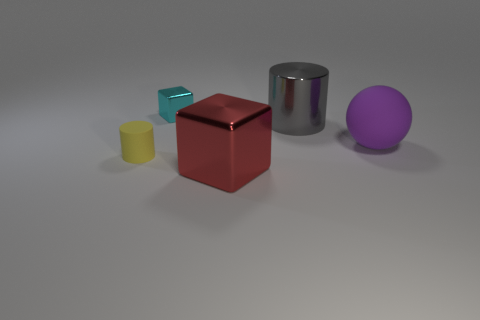There is a metallic cylinder; are there any tiny blocks in front of it?
Your answer should be very brief. No. Are the cylinder that is to the left of the big cylinder and the small thing behind the big cylinder made of the same material?
Keep it short and to the point. No. What number of yellow matte cylinders have the same size as the red thing?
Provide a short and direct response. 0. What is the material of the cylinder that is behind the purple rubber ball?
Make the answer very short. Metal. What number of large gray objects are the same shape as the tiny yellow thing?
Make the answer very short. 1. There is a big thing that is the same material as the small yellow cylinder; what shape is it?
Your response must be concise. Sphere. What is the shape of the thing that is left of the small thing that is behind the tiny thing in front of the large purple object?
Ensure brevity in your answer.  Cylinder. Is the number of small things greater than the number of cyan objects?
Your response must be concise. Yes. What material is the large red object that is the same shape as the cyan thing?
Your response must be concise. Metal. Does the large block have the same material as the cyan object?
Provide a succinct answer. Yes. 